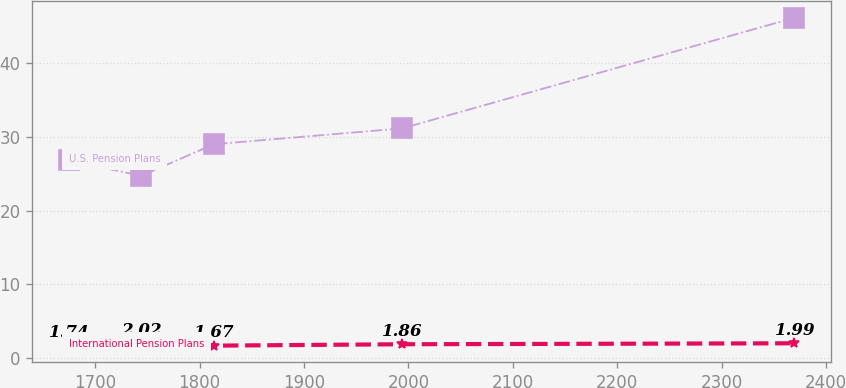Convert chart to OTSL. <chart><loc_0><loc_0><loc_500><loc_500><line_chart><ecel><fcel>U.S. Pension Plans<fcel>International Pension Plans<nl><fcel>1674.5<fcel>26.85<fcel>1.74<nl><fcel>1744.02<fcel>24.7<fcel>2.02<nl><fcel>1813.54<fcel>29<fcel>1.67<nl><fcel>1993.94<fcel>31.15<fcel>1.86<nl><fcel>2369.73<fcel>46.16<fcel>1.99<nl></chart> 